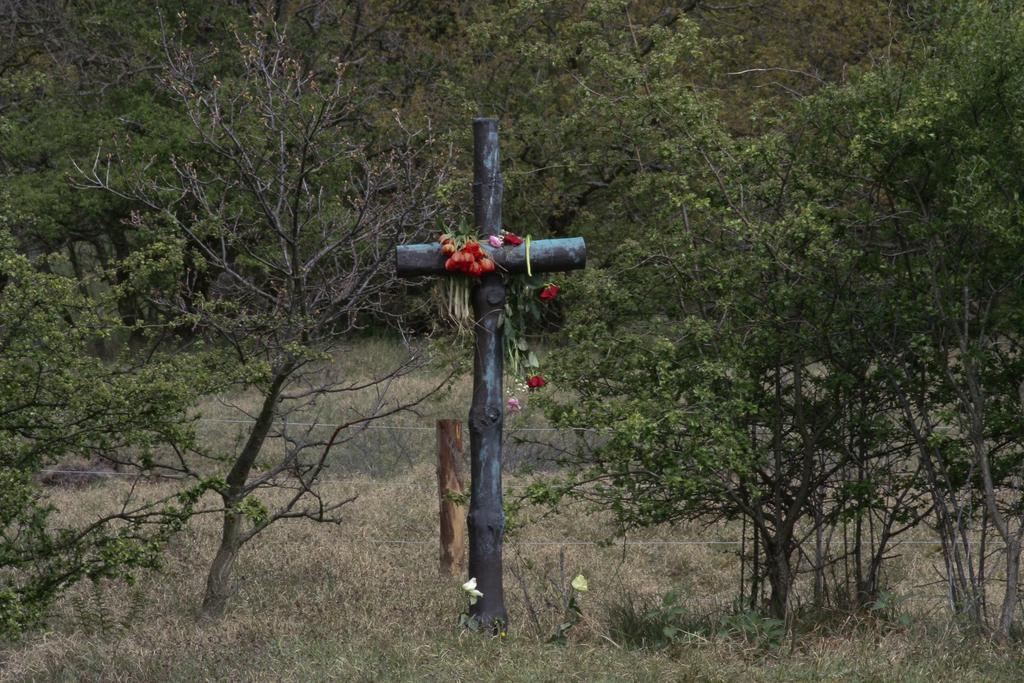What can be found in the grass in the image? There is a cross in the grass. What is placed on top of the cross? There are flowers over the cross. What type of natural elements can be seen in the image? There are trees and plants in the image. What man-made objects are visible in the image? Cables and a wooden stick are visible in the image. How many cows are grazing near the cross in the image? There are no cows present in the image; it only features a cross, flowers, trees, plants, cables, and a wooden stick. 